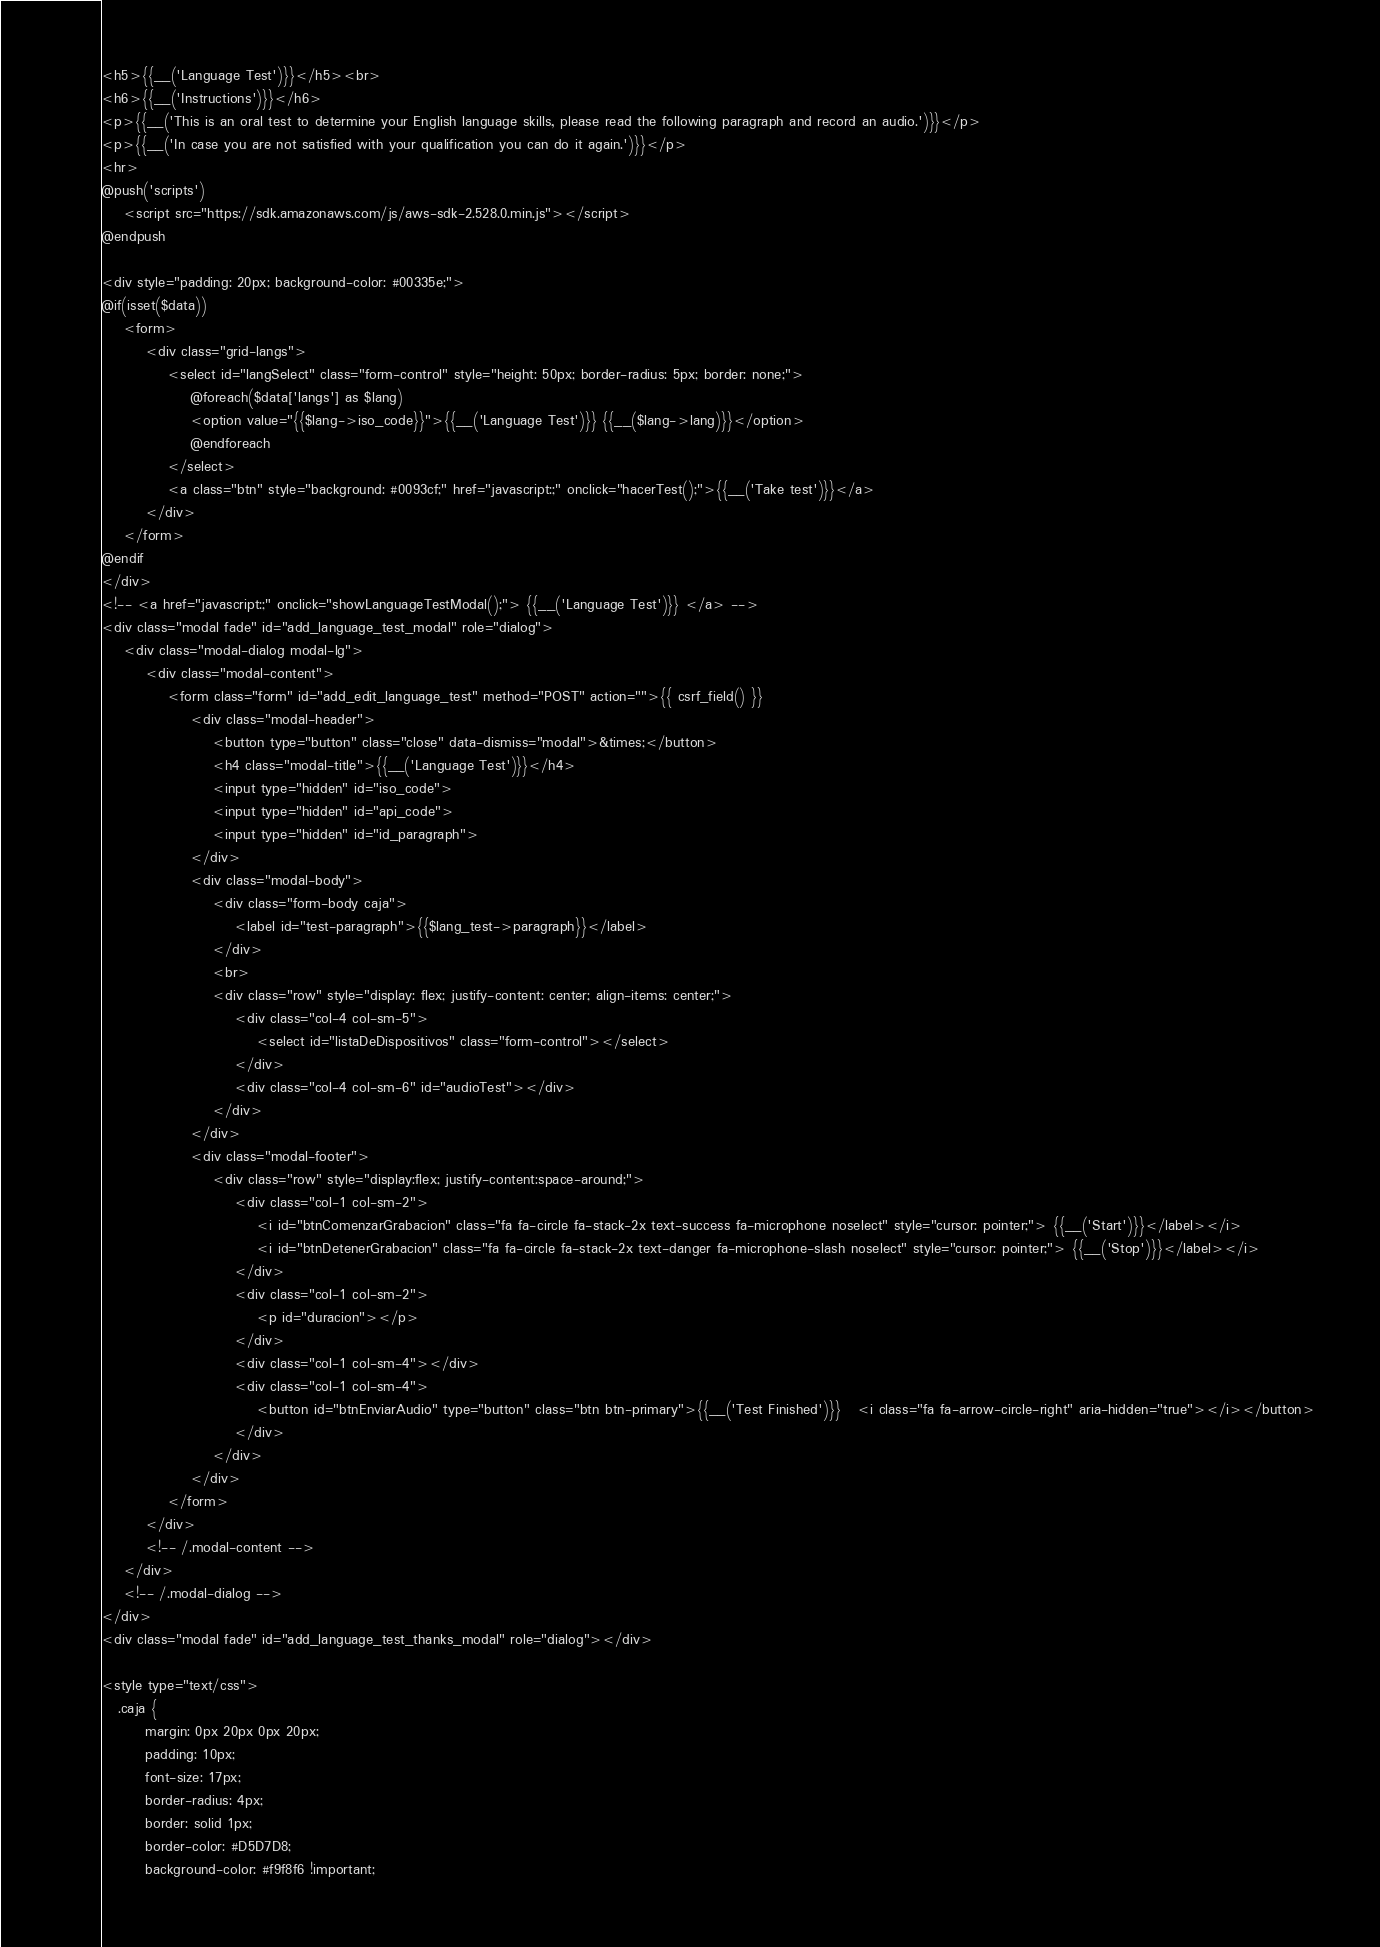Convert code to text. <code><loc_0><loc_0><loc_500><loc_500><_PHP_><h5>{{__('Language Test')}}</h5><br>
<h6>{{__('Instructions')}}</h6>
<p>{{__('This is an oral test to determine your English language skills, please read the following paragraph and record an audio.')}}</p>
<p>{{__('In case you are not satisfied with your qualification you can do it again.')}}</p>
<hr>
@push('scripts')
    <script src="https://sdk.amazonaws.com/js/aws-sdk-2.528.0.min.js"></script>
@endpush

<div style="padding: 20px; background-color: #00335e;">
@if(isset($data))
    <form>
        <div class="grid-langs">
            <select id="langSelect" class="form-control" style="height: 50px; border-radius: 5px; border: none;">
                @foreach($data['langs'] as $lang)
                <option value="{{$lang->iso_code}}">{{__('Language Test')}} {{__($lang->lang)}}</option>
                @endforeach
            </select>
            <a class="btn" style="background: #0093cf;" href="javascript:;" onclick="hacerTest();">{{__('Take test')}}</a>
        </div>
    </form>
@endif
</div>
<!-- <a href="javascript:;" onclick="showLanguageTestModal();"> {{__('Language Test')}} </a> -->
<div class="modal fade" id="add_language_test_modal" role="dialog">
    <div class="modal-dialog modal-lg">
        <div class="modal-content">
            <form class="form" id="add_edit_language_test" method="POST" action="">{{ csrf_field() }}
                <div class="modal-header">
                    <button type="button" class="close" data-dismiss="modal">&times;</button>
                    <h4 class="modal-title">{{__('Language Test')}}</h4>
                    <input type="hidden" id="iso_code">
                    <input type="hidden" id="api_code">
                    <input type="hidden" id="id_paragraph">
                </div>
                <div class="modal-body">
                    <div class="form-body caja">
                        <label id="test-paragraph">{{$lang_test->paragraph}}</label>
                    </div>
                    <br>
                    <div class="row" style="display: flex; justify-content: center; align-items: center;">
                        <div class="col-4 col-sm-5">
                            <select id="listaDeDispositivos" class="form-control"></select>
                        </div>
                        <div class="col-4 col-sm-6" id="audioTest"></div>
                    </div>
                </div>
                <div class="modal-footer">
                    <div class="row" style="display:flex; justify-content:space-around;">
                        <div class="col-1 col-sm-2">
                            <i id="btnComenzarGrabacion" class="fa fa-circle fa-stack-2x text-success fa-microphone noselect" style="cursor: pointer;"> {{__('Start')}}</label></i>
                            <i id="btnDetenerGrabacion" class="fa fa-circle fa-stack-2x text-danger fa-microphone-slash noselect" style="cursor: pointer;"> {{__('Stop')}}</label></i>
                        </div>
                        <div class="col-1 col-sm-2">
                            <p id="duracion"></p>
                        </div>
                        <div class="col-1 col-sm-4"></div>
                        <div class="col-1 col-sm-4">
                            <button id="btnEnviarAudio" type="button" class="btn btn-primary">{{__('Test Finished')}}   <i class="fa fa-arrow-circle-right" aria-hidden="true"></i></button>
                        </div>
                    </div>
                </div>
            </form>
        </div>
        <!-- /.modal-content --> 
    </div>
    <!-- /.modal-dialog -->
</div>
<div class="modal fade" id="add_language_test_thanks_modal" role="dialog"></div>

<style type="text/css">
   .caja {
        margin: 0px 20px 0px 20px;
        padding: 10px;
        font-size: 17px;
        border-radius: 4px;
        border: solid 1px;
        border-color: #D5D7D8;
        background-color: #f9f8f6 !important;</code> 